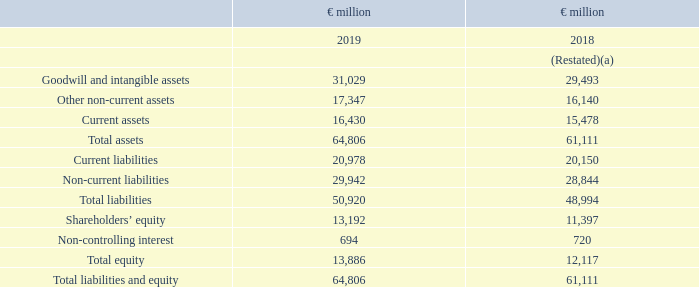Balance sheet
(a) Restated following adoption of IFRS 16. See note 1 and note 24 for further details
Goodwill and intangible assets increased to €31.0 billion (2018: €29.5 billion) mainly as a result of acquisitions which contributed €1.2 billion and favourable currency impact of €0.5 billion driven by strengthening of the US Dollar and Pound Sterling.
In current assets, cash and cash equivalents increased by €1.0 billion. The increase is primarily due to strong cash delivery in several countries which will be used to repay short term debt in due course.
Current and non-current financial liabilities increased by €1.5 billion as a result of commercial paper issue and bank borrowings.
The net pension plan deficit was lower than prior year by €0.7 billion as
gains from investment performance exceeded the increase in liabilities.
What caused the increase in Goodwill in 2019? Mainly as a result of acquisitions which contributed €1.2 billion and favourable currency impact of €0.5 billion driven by strengthening of the us dollar and pound sterling. What caused the increase in the cash and cash equivalents in 2019? The increase is primarily due to strong cash delivery in several countries which will be used to repay short term debt in due course. What caused the increase in the Current and non-current financial liabilities in 2019? As a result of commercial paper issue and bank borrowings. What is the increase in Goodwill and intangible assets from 2018 to 2019?
Answer scale should be: million. 31,029 - 29,493
Answer: 1536. What is the percentage increase / (decrease) in Total Assets from 2018?
Answer scale should be: percent. 64,806 / 61,111 - 1
Answer: 6.05. What is the Current Ratio in 2019? 16,430 / 20,978
Answer: 0.78. 